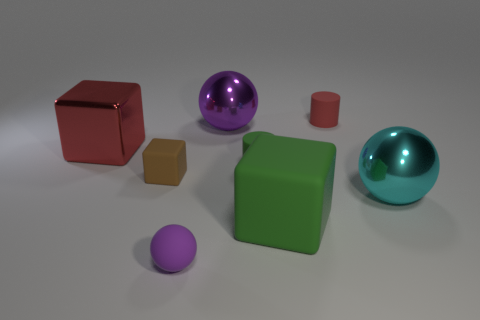How many objects are there in total, and can you categorize them by shape? There are six objects present. We have two cubes, one larger in red and another smaller in brown, two spheres in purple and teal, and two cylinders, one green and one smaller in red. 